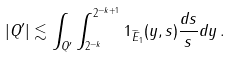<formula> <loc_0><loc_0><loc_500><loc_500>| Q ^ { \prime } | \lesssim \int _ { Q ^ { \prime } } \int _ { 2 ^ { - k } } ^ { 2 ^ { - k + 1 } } 1 _ { \widetilde { E } _ { 1 } } ( y , s ) \frac { d s } { s } d y \, .</formula> 